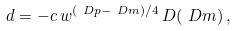Convert formula to latex. <formula><loc_0><loc_0><loc_500><loc_500>d & = - c \, w ^ { { ( \ D p - \ D m ) } / { 4 } } \, D ( \ D m ) \, , \\</formula> 